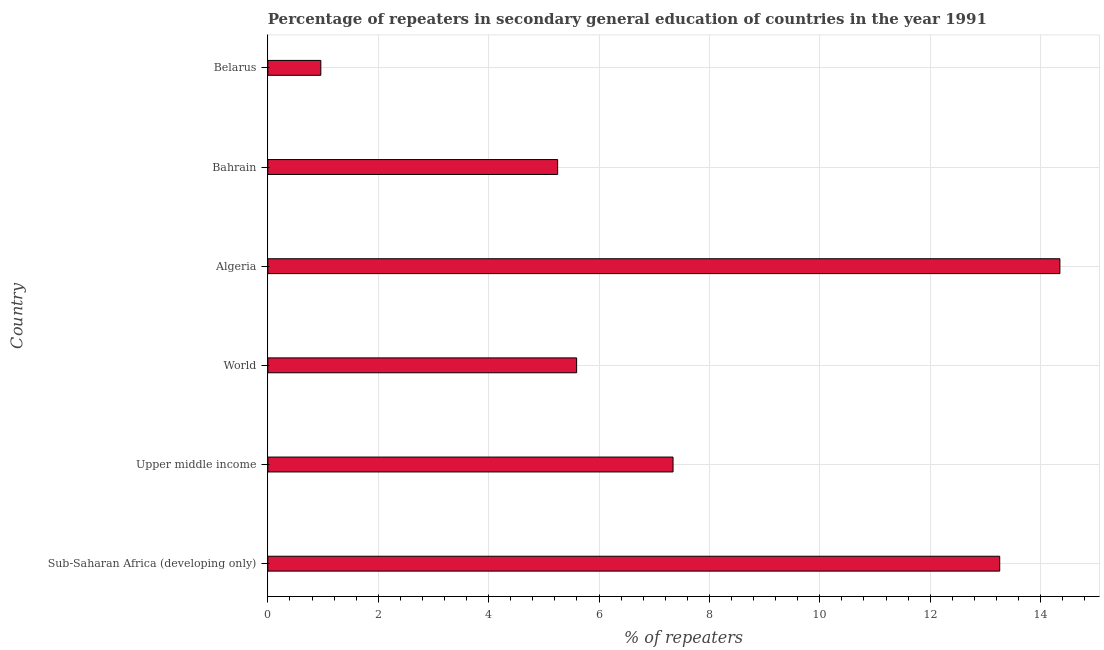Does the graph contain any zero values?
Provide a short and direct response. No. What is the title of the graph?
Provide a succinct answer. Percentage of repeaters in secondary general education of countries in the year 1991. What is the label or title of the X-axis?
Provide a short and direct response. % of repeaters. What is the label or title of the Y-axis?
Give a very brief answer. Country. What is the percentage of repeaters in Bahrain?
Your answer should be compact. 5.25. Across all countries, what is the maximum percentage of repeaters?
Provide a succinct answer. 14.35. Across all countries, what is the minimum percentage of repeaters?
Offer a very short reply. 0.96. In which country was the percentage of repeaters maximum?
Provide a succinct answer. Algeria. In which country was the percentage of repeaters minimum?
Give a very brief answer. Belarus. What is the sum of the percentage of repeaters?
Your response must be concise. 46.76. What is the difference between the percentage of repeaters in Algeria and Upper middle income?
Ensure brevity in your answer.  7.01. What is the average percentage of repeaters per country?
Give a very brief answer. 7.79. What is the median percentage of repeaters?
Ensure brevity in your answer.  6.47. What is the ratio of the percentage of repeaters in Belarus to that in World?
Offer a terse response. 0.17. What is the difference between the highest and the second highest percentage of repeaters?
Your response must be concise. 1.09. Is the sum of the percentage of repeaters in Sub-Saharan Africa (developing only) and Upper middle income greater than the maximum percentage of repeaters across all countries?
Give a very brief answer. Yes. What is the difference between the highest and the lowest percentage of repeaters?
Give a very brief answer. 13.39. In how many countries, is the percentage of repeaters greater than the average percentage of repeaters taken over all countries?
Ensure brevity in your answer.  2. How many countries are there in the graph?
Offer a terse response. 6. What is the difference between two consecutive major ticks on the X-axis?
Provide a succinct answer. 2. Are the values on the major ticks of X-axis written in scientific E-notation?
Provide a succinct answer. No. What is the % of repeaters of Sub-Saharan Africa (developing only)?
Make the answer very short. 13.26. What is the % of repeaters in Upper middle income?
Give a very brief answer. 7.34. What is the % of repeaters of World?
Your answer should be very brief. 5.59. What is the % of repeaters in Algeria?
Offer a very short reply. 14.35. What is the % of repeaters of Bahrain?
Keep it short and to the point. 5.25. What is the % of repeaters of Belarus?
Your response must be concise. 0.96. What is the difference between the % of repeaters in Sub-Saharan Africa (developing only) and Upper middle income?
Ensure brevity in your answer.  5.92. What is the difference between the % of repeaters in Sub-Saharan Africa (developing only) and World?
Ensure brevity in your answer.  7.67. What is the difference between the % of repeaters in Sub-Saharan Africa (developing only) and Algeria?
Your answer should be very brief. -1.09. What is the difference between the % of repeaters in Sub-Saharan Africa (developing only) and Bahrain?
Give a very brief answer. 8.01. What is the difference between the % of repeaters in Sub-Saharan Africa (developing only) and Belarus?
Give a very brief answer. 12.3. What is the difference between the % of repeaters in Upper middle income and World?
Your answer should be compact. 1.75. What is the difference between the % of repeaters in Upper middle income and Algeria?
Ensure brevity in your answer.  -7.01. What is the difference between the % of repeaters in Upper middle income and Bahrain?
Your answer should be compact. 2.09. What is the difference between the % of repeaters in Upper middle income and Belarus?
Keep it short and to the point. 6.38. What is the difference between the % of repeaters in World and Algeria?
Provide a short and direct response. -8.76. What is the difference between the % of repeaters in World and Bahrain?
Your response must be concise. 0.34. What is the difference between the % of repeaters in World and Belarus?
Offer a terse response. 4.63. What is the difference between the % of repeaters in Algeria and Bahrain?
Offer a terse response. 9.1. What is the difference between the % of repeaters in Algeria and Belarus?
Your answer should be compact. 13.39. What is the difference between the % of repeaters in Bahrain and Belarus?
Make the answer very short. 4.29. What is the ratio of the % of repeaters in Sub-Saharan Africa (developing only) to that in Upper middle income?
Offer a terse response. 1.81. What is the ratio of the % of repeaters in Sub-Saharan Africa (developing only) to that in World?
Your answer should be compact. 2.37. What is the ratio of the % of repeaters in Sub-Saharan Africa (developing only) to that in Algeria?
Offer a very short reply. 0.92. What is the ratio of the % of repeaters in Sub-Saharan Africa (developing only) to that in Bahrain?
Provide a short and direct response. 2.53. What is the ratio of the % of repeaters in Sub-Saharan Africa (developing only) to that in Belarus?
Offer a very short reply. 13.81. What is the ratio of the % of repeaters in Upper middle income to that in World?
Provide a succinct answer. 1.31. What is the ratio of the % of repeaters in Upper middle income to that in Algeria?
Ensure brevity in your answer.  0.51. What is the ratio of the % of repeaters in Upper middle income to that in Bahrain?
Keep it short and to the point. 1.4. What is the ratio of the % of repeaters in Upper middle income to that in Belarus?
Your answer should be very brief. 7.65. What is the ratio of the % of repeaters in World to that in Algeria?
Keep it short and to the point. 0.39. What is the ratio of the % of repeaters in World to that in Bahrain?
Ensure brevity in your answer.  1.07. What is the ratio of the % of repeaters in World to that in Belarus?
Provide a succinct answer. 5.83. What is the ratio of the % of repeaters in Algeria to that in Bahrain?
Ensure brevity in your answer.  2.73. What is the ratio of the % of repeaters in Algeria to that in Belarus?
Provide a succinct answer. 14.95. What is the ratio of the % of repeaters in Bahrain to that in Belarus?
Offer a very short reply. 5.47. 